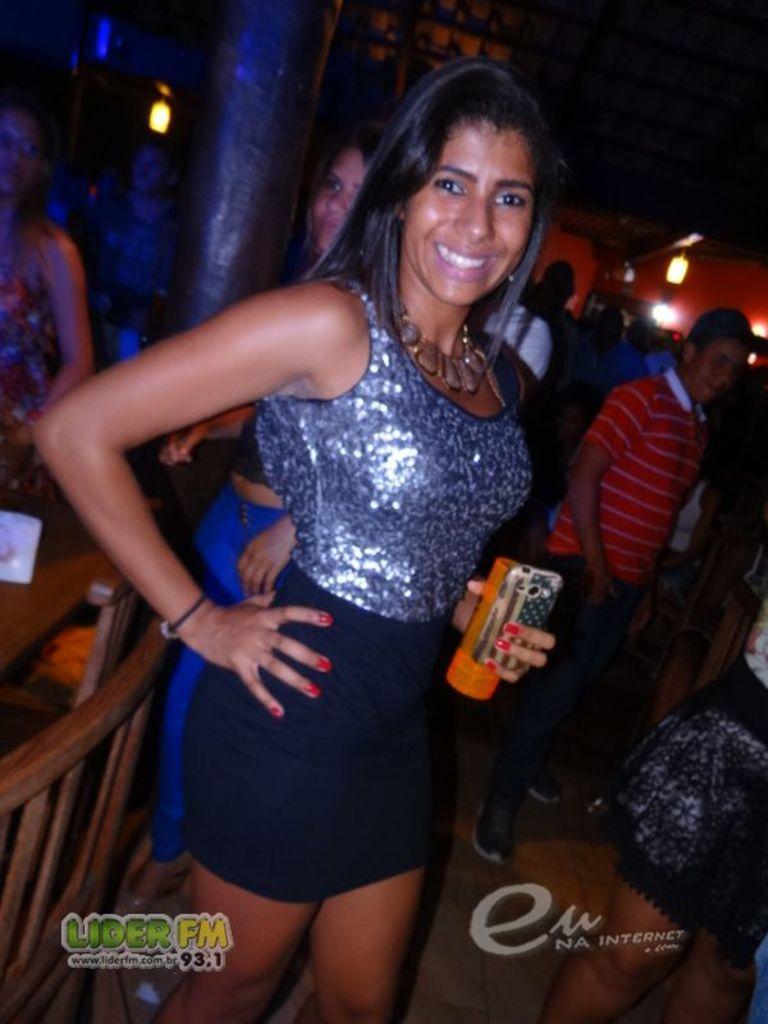Can you describe this image briefly? This picture describes about group of people, in the middle of the given image we can see a woman, she is smiling and she is holding a mobile and bottle in her hand, in the background we can see few lights. 